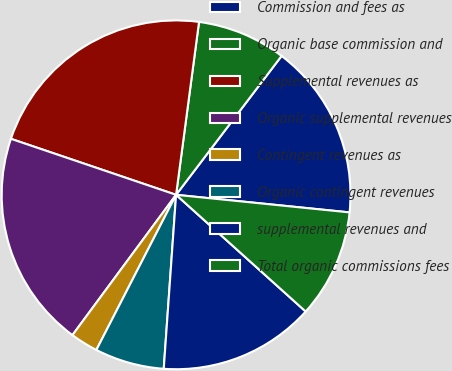<chart> <loc_0><loc_0><loc_500><loc_500><pie_chart><fcel>Commission and fees as<fcel>Organic base commission and<fcel>Supplemental revenues as<fcel>Organic supplemental revenues<fcel>Contingent revenues as<fcel>Organic contingent revenues<fcel>supplemental revenues and<fcel>Total organic commissions fees<nl><fcel>16.27%<fcel>8.24%<fcel>21.9%<fcel>20.08%<fcel>2.57%<fcel>6.43%<fcel>14.46%<fcel>10.06%<nl></chart> 